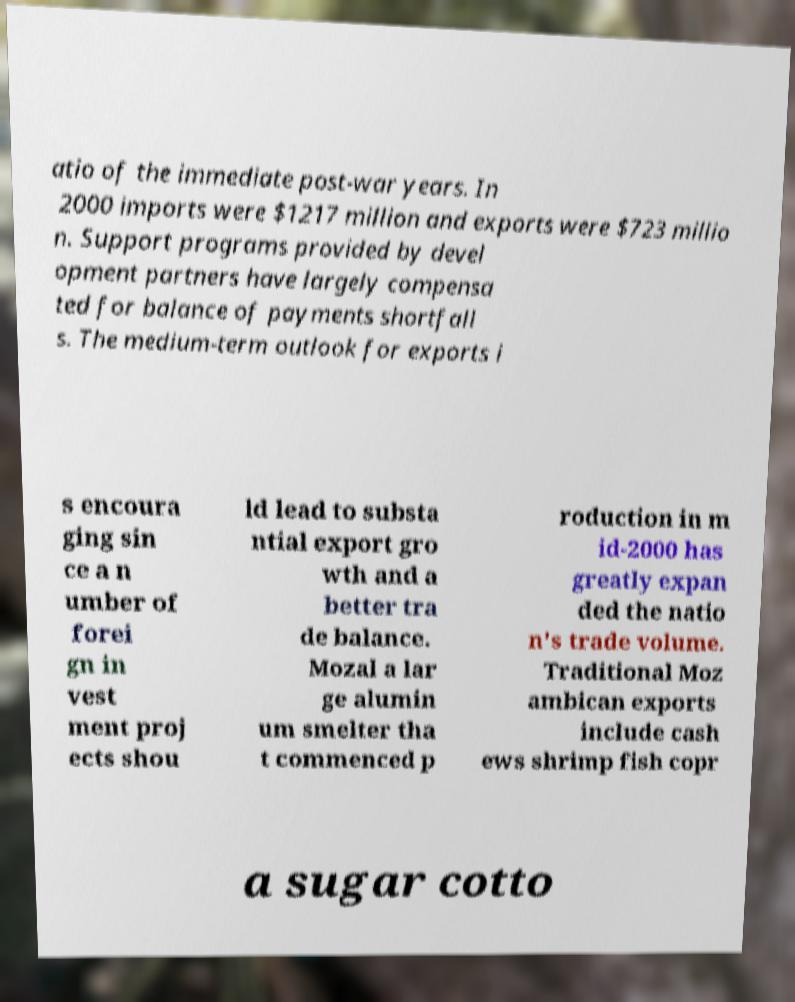There's text embedded in this image that I need extracted. Can you transcribe it verbatim? atio of the immediate post-war years. In 2000 imports were $1217 million and exports were $723 millio n. Support programs provided by devel opment partners have largely compensa ted for balance of payments shortfall s. The medium-term outlook for exports i s encoura ging sin ce a n umber of forei gn in vest ment proj ects shou ld lead to substa ntial export gro wth and a better tra de balance. Mozal a lar ge alumin um smelter tha t commenced p roduction in m id-2000 has greatly expan ded the natio n's trade volume. Traditional Moz ambican exports include cash ews shrimp fish copr a sugar cotto 